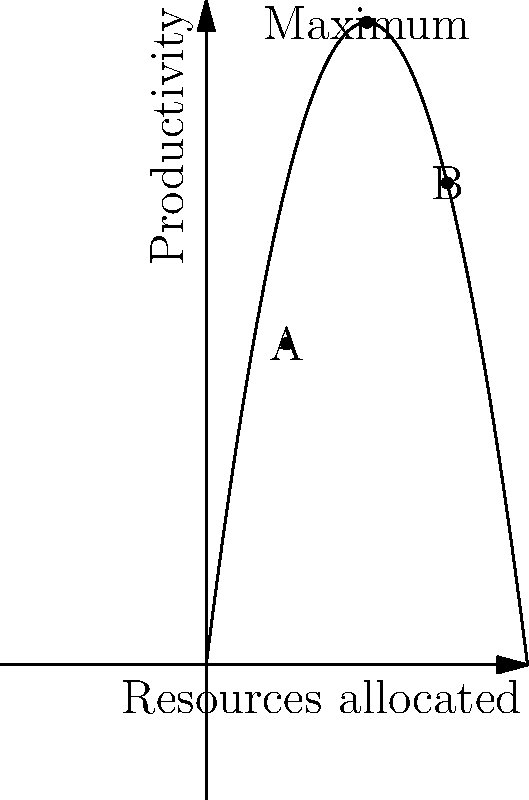In a tech project, resource allocation follows the productivity curve $P(x) = -0.5x^2 + 8x$, where $x$ represents the number of resources allocated and $P(x)$ represents the productivity. Given points A(4, 16) and B(12, 24) on the curve, determine the optimal number of resources to maximize productivity and calculate the increase in productivity from the current allocation at point A. 1. To find the optimal number of resources, we need to find the maximum of the function $P(x) = -0.5x^2 + 8x$.

2. The maximum occurs at the vertex of the parabola. For a quadratic function $ax^2 + bx + c$, the x-coordinate of the vertex is given by $x = -\frac{b}{2a}$.

3. In our case, $a = -0.5$ and $b = 8$. So, the optimal number of resources is:
   $x = -\frac{8}{2(-0.5)} = 8$

4. To find the maximum productivity, we substitute $x = 8$ into the original function:
   $P(8) = -0.5(8)^2 + 8(8) = -32 + 64 = 32$

5. The current allocation at point A is 4 resources, producing a productivity of 16.

6. The increase in productivity from point A to the maximum is:
   $32 - 16 = 16$
Answer: Optimal resources: 8; Productivity increase: 16 